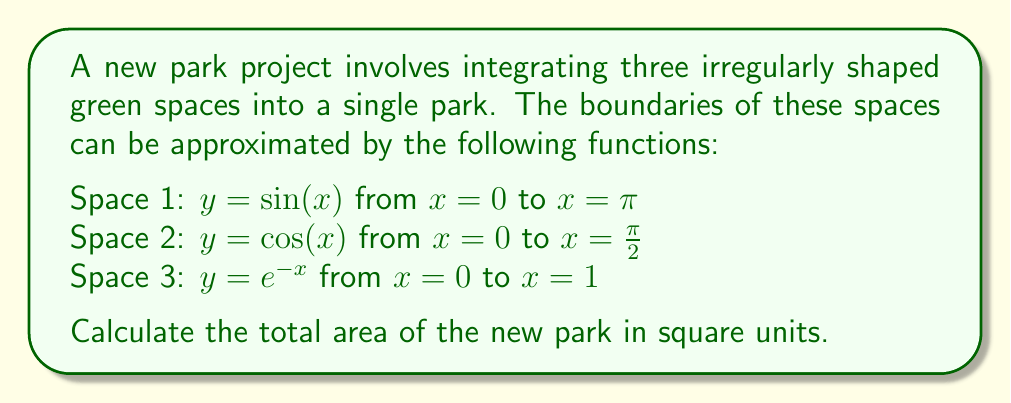Can you answer this question? To find the total area of the park, we need to calculate the areas of each space using definite integrals and then sum them up.

1. For Space 1:
   Area = $\int_0^\pi \sin(x) dx$
   $= [-\cos(x)]_0^\pi = -\cos(\pi) - (-\cos(0)) = 1 + 1 = 2$ square units

2. For Space 2:
   Area = $\int_0^{\frac{\pi}{2}} \cos(x) dx$
   $= [\sin(x)]_0^{\frac{\pi}{2}} = \sin(\frac{\pi}{2}) - \sin(0) = 1 - 0 = 1$ square unit

3. For Space 3:
   Area = $\int_0^1 e^{-x} dx$
   $= [-e^{-x}]_0^1 = -e^{-1} - (-e^0) = -\frac{1}{e} + 1 = 1 - \frac{1}{e}$ square units

Total area = Sum of all three spaces
$= 2 + 1 + (1 - \frac{1}{e})$
$= 4 - \frac{1}{e}$ square units
Answer: $4 - \frac{1}{e}$ square units 